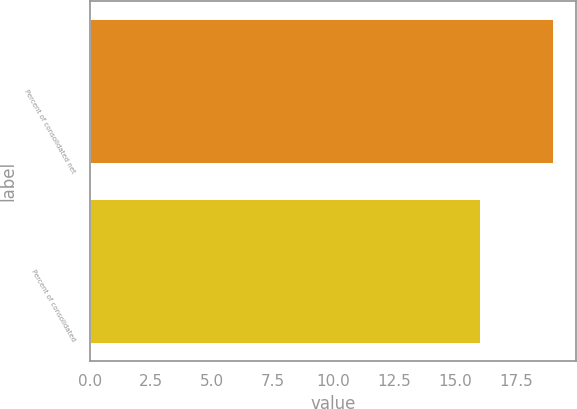Convert chart. <chart><loc_0><loc_0><loc_500><loc_500><bar_chart><fcel>Percent of consolidated net<fcel>Percent of consolidated<nl><fcel>19<fcel>16<nl></chart> 